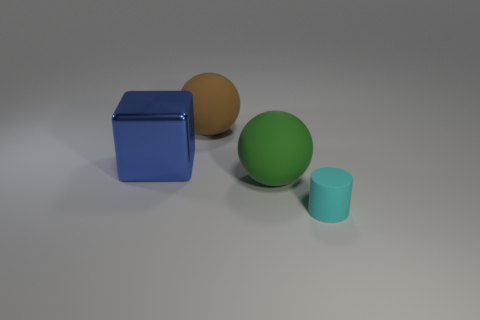Subtract all gray spheres. Subtract all brown cylinders. How many spheres are left? 2 Add 1 brown rubber objects. How many objects exist? 5 Subtract all cylinders. How many objects are left? 3 Add 2 big gray rubber blocks. How many big gray rubber blocks exist? 2 Subtract 0 cyan balls. How many objects are left? 4 Subtract all green balls. Subtract all green rubber things. How many objects are left? 2 Add 2 large blue objects. How many large blue objects are left? 3 